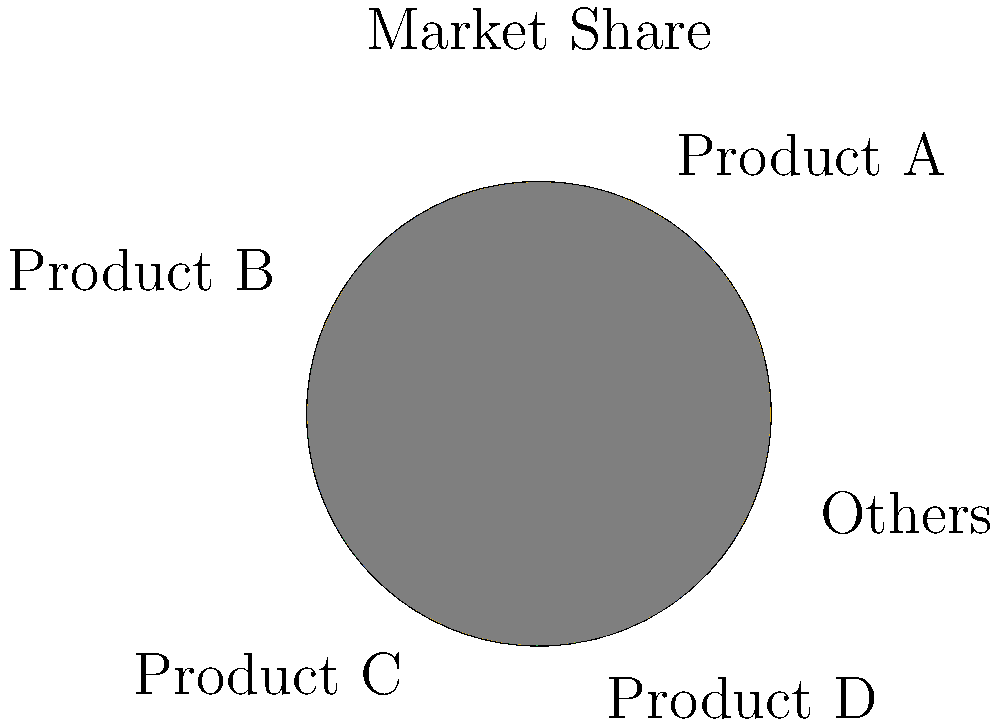Your company's flagship product, Product A, has been recalled due to a safety issue. Initial estimates suggest a potential 40% loss in market share for Product A. Given the pie chart representing your current market share distribution, calculate the new overall market share percentage for Product A after the recall, assuming competitors gain equally from the loss. To solve this problem, we'll follow these steps:

1. Identify Product A's current market share:
   From the pie chart, we can see that Product A has 30% market share.

2. Calculate the loss in market share:
   The estimated loss is 40% of Product A's current share.
   $40\% \text{ of } 30\% = 0.4 \times 30\% = 12\%$

3. Calculate Product A's new market share:
   $30\% - 12\% = 18\%$

4. Determine how the lost market share is distributed:
   The 12% loss is assumed to be distributed equally among the other four segments (Product B, Product C, Product D, and Others).
   $12\% \div 4 = 3\%$ gain for each competitor

5. Calculate the new total market size:
   The total market size remains 100%, but the distribution changes.

6. Calculate Product A's new overall market share percentage:
   $\frac{18}{100} \times 100\% = 18\%$

Therefore, after the recall, Product A's new overall market share percentage would be 18%.
Answer: 18% 